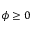Convert formula to latex. <formula><loc_0><loc_0><loc_500><loc_500>\phi \geq 0</formula> 